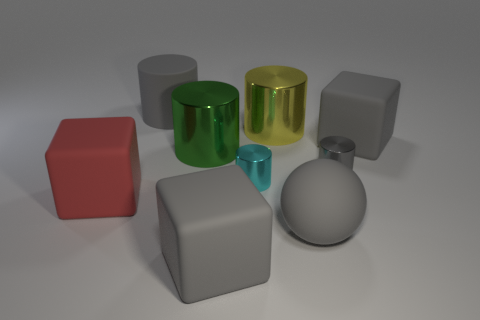Subtract all large gray rubber cylinders. How many cylinders are left? 4 Subtract 2 cylinders. How many cylinders are left? 3 Subtract all green cylinders. How many cylinders are left? 4 Subtract all green cylinders. Subtract all yellow balls. How many cylinders are left? 4 Subtract all cubes. How many objects are left? 6 Add 7 large matte blocks. How many large matte blocks are left? 10 Add 1 small cyan metal cylinders. How many small cyan metal cylinders exist? 2 Subtract 1 gray cylinders. How many objects are left? 8 Subtract all tiny cyan objects. Subtract all green shiny balls. How many objects are left? 8 